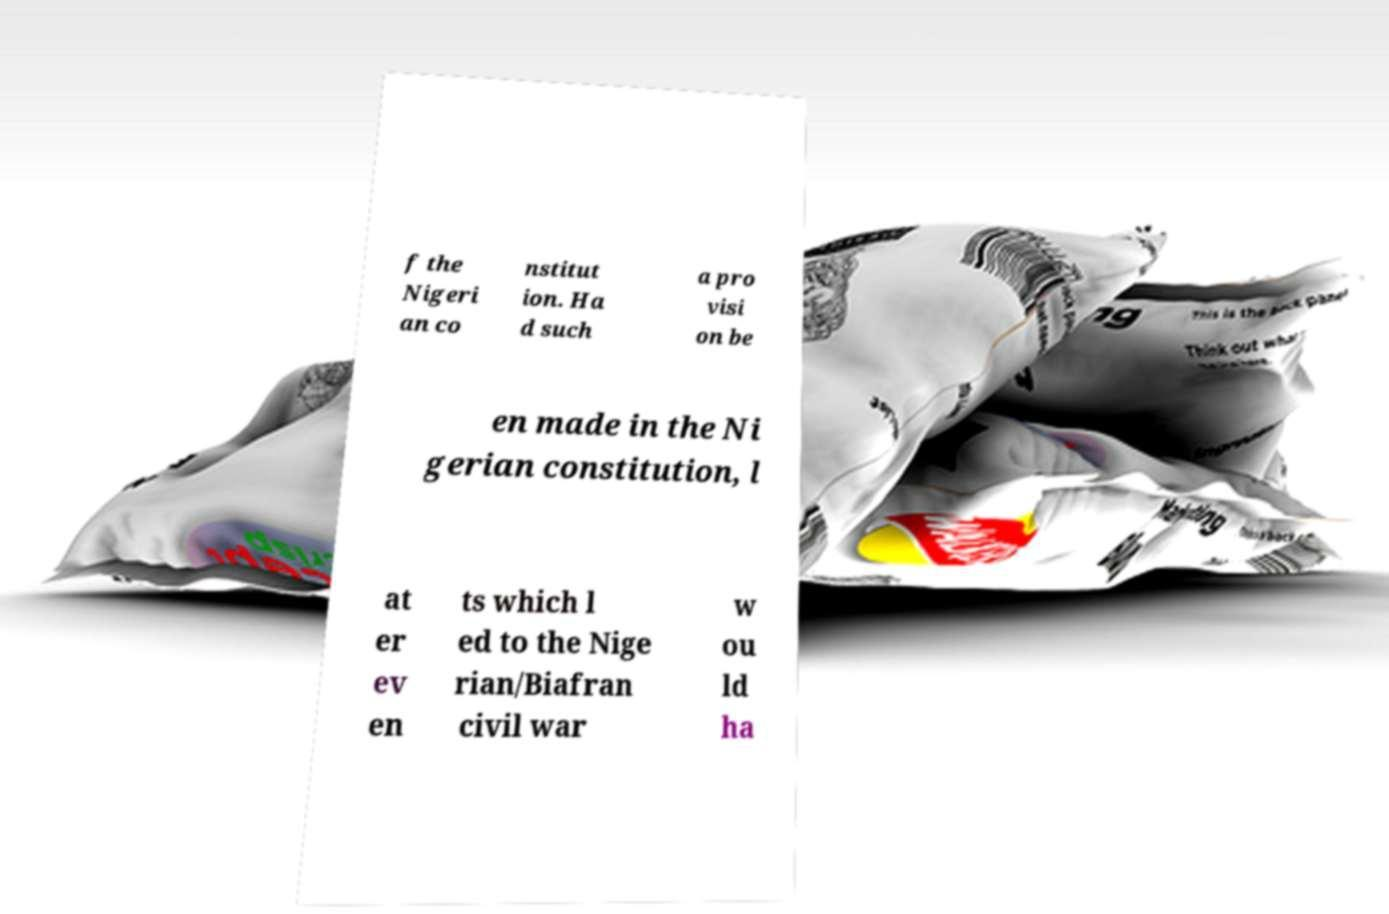Please read and relay the text visible in this image. What does it say? f the Nigeri an co nstitut ion. Ha d such a pro visi on be en made in the Ni gerian constitution, l at er ev en ts which l ed to the Nige rian/Biafran civil war w ou ld ha 